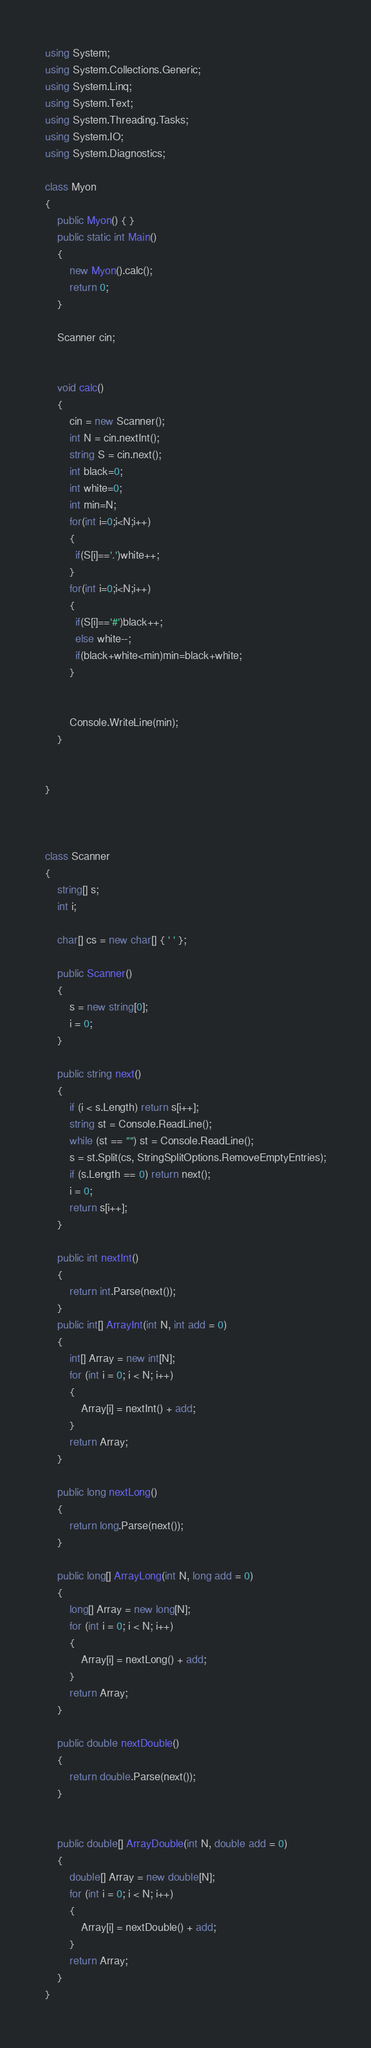Convert code to text. <code><loc_0><loc_0><loc_500><loc_500><_C#_>using System;
using System.Collections.Generic;
using System.Linq;
using System.Text;
using System.Threading.Tasks;
using System.IO;
using System.Diagnostics;

class Myon
{
    public Myon() { }
    public static int Main()
    {
        new Myon().calc();
        return 0;
    }

    Scanner cin;


    void calc()
    {
        cin = new Scanner();
        int N = cin.nextInt();
        string S = cin.next();
        int black=0;
        int white=0;
        int min=N;
        for(int i=0;i<N;i++)
        {
          if(S[i]=='.')white++;
        }
        for(int i=0;i<N;i++)
        {
          if(S[i]=='#')black++;
          else white--;
          if(black+white<min)min=black+white;
        }
      
        
        Console.WriteLine(min);
    }


}



class Scanner
{
    string[] s;
    int i;

    char[] cs = new char[] { ' ' };

    public Scanner()
    {
        s = new string[0];
        i = 0;
    }
    
    public string next()
    {
        if (i < s.Length) return s[i++];
        string st = Console.ReadLine();
        while (st == "") st = Console.ReadLine();
        s = st.Split(cs, StringSplitOptions.RemoveEmptyEntries);
        if (s.Length == 0) return next();
        i = 0;
        return s[i++];
    }

    public int nextInt()
    {
        return int.Parse(next());
    }
    public int[] ArrayInt(int N, int add = 0)
    {
        int[] Array = new int[N];
        for (int i = 0; i < N; i++)
        {
            Array[i] = nextInt() + add;
        }
        return Array;
    }

    public long nextLong()
    {
        return long.Parse(next());
    }

    public long[] ArrayLong(int N, long add = 0)
    {
        long[] Array = new long[N];
        for (int i = 0; i < N; i++)
        {
            Array[i] = nextLong() + add;
        }
        return Array;
    }

    public double nextDouble()
    {
        return double.Parse(next());
    }


    public double[] ArrayDouble(int N, double add = 0)
    {
        double[] Array = new double[N];
        for (int i = 0; i < N; i++)
        {
            Array[i] = nextDouble() + add;
        }
        return Array;
    }
}</code> 